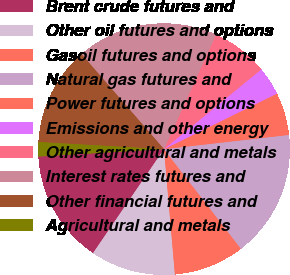Convert chart. <chart><loc_0><loc_0><loc_500><loc_500><pie_chart><fcel>Brent crude futures and<fcel>Other oil futures and options<fcel>Gasoil futures and options<fcel>Natural gas futures and<fcel>Power futures and options<fcel>Emissions and other energy<fcel>Other agricultural and metals<fcel>Interest rates futures and<fcel>Other financial futures and<fcel>Agricultural and metals<nl><fcel>14.53%<fcel>10.91%<fcel>9.09%<fcel>16.34%<fcel>5.47%<fcel>3.66%<fcel>7.28%<fcel>18.16%<fcel>12.72%<fcel>1.84%<nl></chart> 